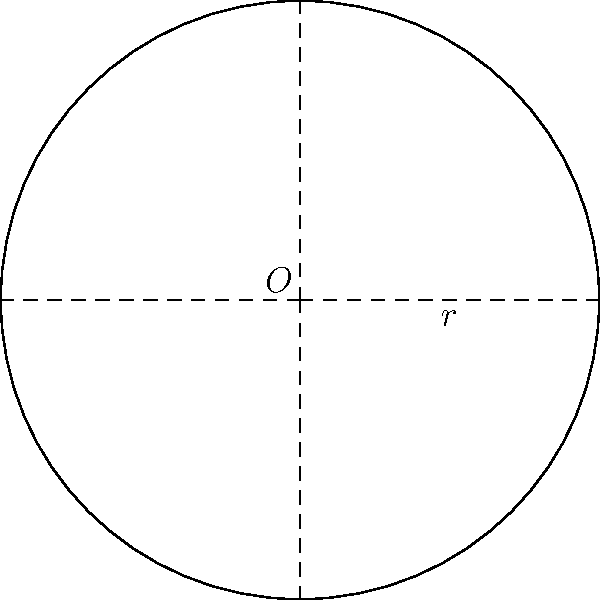Une nouvelle gare ferroviaire nécessite l'installation d'une plaque tournante circulaire pour les locomotives. Si le rayon de la plaque tournante est de 20 mètres, quelle est la superficie minimale de terrain nécessaire pour son installation, arrondie au mètre carré près ? Pour résoudre ce problème, suivons ces étapes :

1) La forme de la plaque tournante est un cercle. La formule pour calculer l'aire d'un cercle est :

   $$A = \pi r^2$$

   Où $A$ est l'aire et $r$ est le rayon.

2) On nous donne le rayon : $r = 20$ mètres.

3) Substituons ces valeurs dans la formule :

   $$A = \pi \times 20^2$$

4) Calculons :
   $$A = \pi \times 400 = 400\pi \approx 1256,64 \text{ m}^2$$

5) Arrondissons au mètre carré le plus proche :
   $$1256,64 \text{ m}^2 \approx 1257 \text{ m}^2$$

Donc, la superficie minimale de terrain nécessaire est d'environ 1257 mètres carrés.
Answer: 1257 m² 